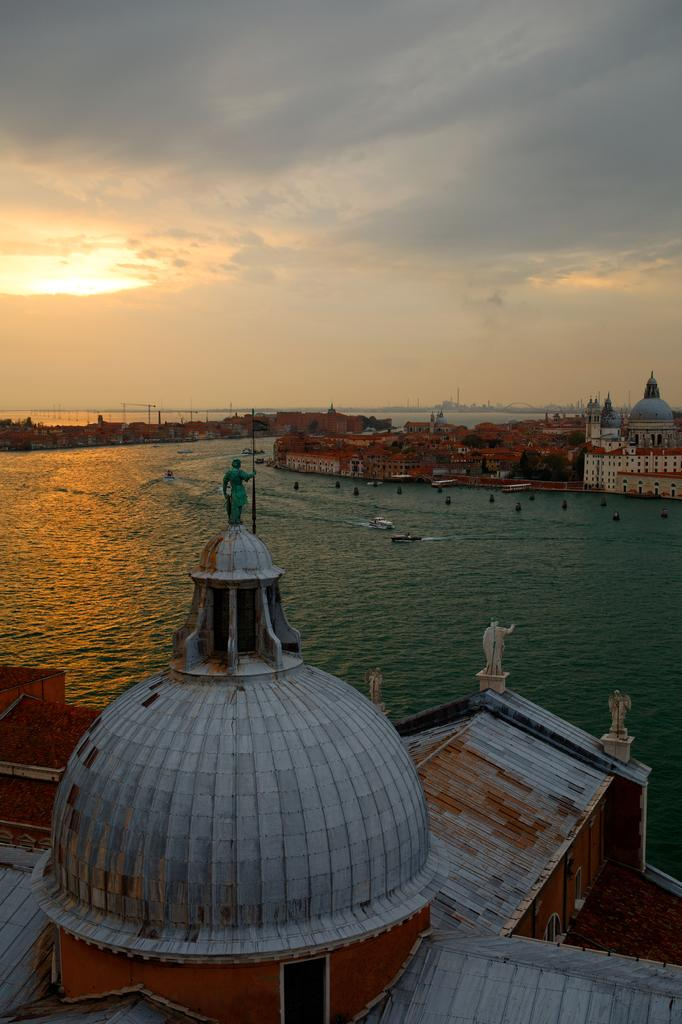What type of structures can be seen in the image? There are buildings in the image. What is located in the water in the image? There are boats in the water. What is the condition of the sky in the image? The sky is cloudy in the image. Can you describe the lighting in the image? Sunlight is visible in the image. What type of stamp is being used to secure the boats in the image? There is no stamp present in the image; the boats are floating in the water. What credit card is being used to purchase the buildings in the image? There is no credit card or transaction being depicted in the image; it simply shows buildings and boats. 